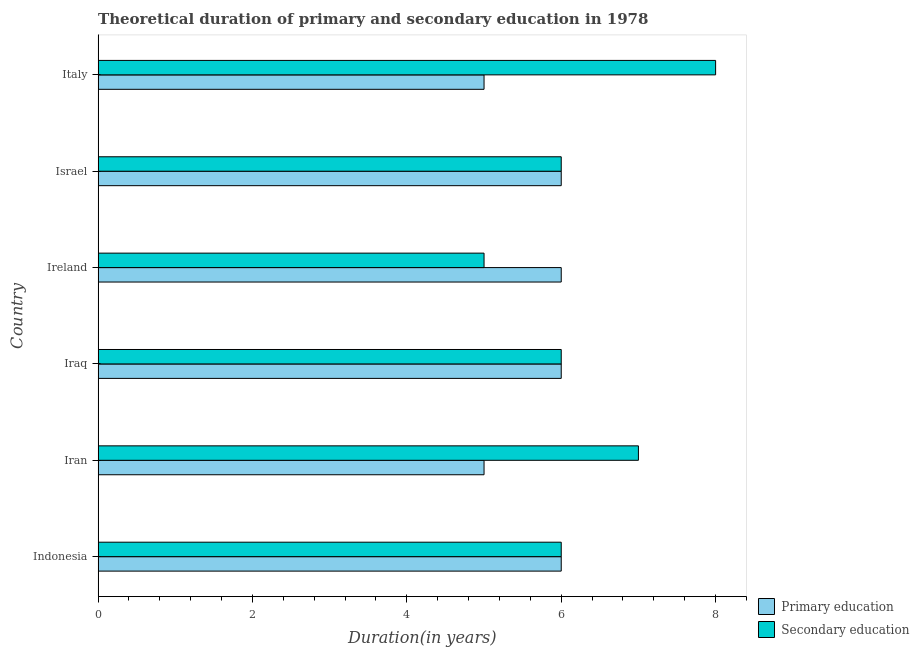How many groups of bars are there?
Provide a short and direct response. 6. How many bars are there on the 3rd tick from the top?
Offer a terse response. 2. How many bars are there on the 4th tick from the bottom?
Offer a terse response. 2. What is the label of the 5th group of bars from the top?
Provide a succinct answer. Iran. In how many cases, is the number of bars for a given country not equal to the number of legend labels?
Your response must be concise. 0. What is the duration of secondary education in Iran?
Offer a very short reply. 7. Across all countries, what is the maximum duration of secondary education?
Offer a very short reply. 8. Across all countries, what is the minimum duration of primary education?
Offer a very short reply. 5. In which country was the duration of secondary education minimum?
Your response must be concise. Ireland. What is the total duration of secondary education in the graph?
Your response must be concise. 38. What is the difference between the duration of secondary education in Indonesia and that in Italy?
Offer a very short reply. -2. What is the difference between the duration of primary education in Indonesia and the duration of secondary education in Iraq?
Keep it short and to the point. 0. What is the average duration of secondary education per country?
Your response must be concise. 6.33. In how many countries, is the duration of primary education greater than 4.4 years?
Offer a very short reply. 6. What is the ratio of the duration of secondary education in Iran to that in Israel?
Ensure brevity in your answer.  1.17. Is the duration of primary education in Iran less than that in Ireland?
Provide a short and direct response. Yes. Is the difference between the duration of primary education in Indonesia and Israel greater than the difference between the duration of secondary education in Indonesia and Israel?
Offer a very short reply. No. What is the difference between the highest and the second highest duration of secondary education?
Provide a succinct answer. 1. What is the difference between the highest and the lowest duration of secondary education?
Provide a succinct answer. 3. Is the sum of the duration of secondary education in Iran and Ireland greater than the maximum duration of primary education across all countries?
Provide a succinct answer. Yes. What does the 2nd bar from the top in Italy represents?
Ensure brevity in your answer.  Primary education. What does the 2nd bar from the bottom in Indonesia represents?
Offer a very short reply. Secondary education. How many bars are there?
Your answer should be very brief. 12. Are all the bars in the graph horizontal?
Provide a short and direct response. Yes. How many countries are there in the graph?
Offer a very short reply. 6. Does the graph contain grids?
Give a very brief answer. No. How are the legend labels stacked?
Your answer should be very brief. Vertical. What is the title of the graph?
Offer a terse response. Theoretical duration of primary and secondary education in 1978. Does "Ages 15-24" appear as one of the legend labels in the graph?
Provide a short and direct response. No. What is the label or title of the X-axis?
Your answer should be compact. Duration(in years). What is the Duration(in years) in Primary education in Indonesia?
Your answer should be compact. 6. What is the Duration(in years) of Secondary education in Indonesia?
Offer a terse response. 6. What is the Duration(in years) in Secondary education in Iraq?
Your answer should be very brief. 6. What is the Duration(in years) of Secondary education in Israel?
Provide a succinct answer. 6. What is the Duration(in years) of Primary education in Italy?
Your response must be concise. 5. Across all countries, what is the maximum Duration(in years) in Secondary education?
Offer a terse response. 8. What is the difference between the Duration(in years) of Primary education in Indonesia and that in Iran?
Offer a terse response. 1. What is the difference between the Duration(in years) of Primary education in Indonesia and that in Iraq?
Keep it short and to the point. 0. What is the difference between the Duration(in years) of Primary education in Indonesia and that in Ireland?
Your answer should be very brief. 0. What is the difference between the Duration(in years) of Secondary education in Iran and that in Iraq?
Offer a terse response. 1. What is the difference between the Duration(in years) of Secondary education in Iran and that in Ireland?
Provide a succinct answer. 2. What is the difference between the Duration(in years) of Primary education in Iran and that in Israel?
Provide a succinct answer. -1. What is the difference between the Duration(in years) in Secondary education in Iran and that in Israel?
Your answer should be very brief. 1. What is the difference between the Duration(in years) of Secondary education in Ireland and that in Israel?
Offer a very short reply. -1. What is the difference between the Duration(in years) of Primary education in Ireland and that in Italy?
Give a very brief answer. 1. What is the difference between the Duration(in years) of Secondary education in Israel and that in Italy?
Offer a terse response. -2. What is the difference between the Duration(in years) in Primary education in Indonesia and the Duration(in years) in Secondary education in Iraq?
Ensure brevity in your answer.  0. What is the difference between the Duration(in years) in Primary education in Indonesia and the Duration(in years) in Secondary education in Ireland?
Ensure brevity in your answer.  1. What is the difference between the Duration(in years) in Primary education in Indonesia and the Duration(in years) in Secondary education in Israel?
Your answer should be very brief. 0. What is the difference between the Duration(in years) in Primary education in Indonesia and the Duration(in years) in Secondary education in Italy?
Ensure brevity in your answer.  -2. What is the difference between the Duration(in years) in Primary education in Iran and the Duration(in years) in Secondary education in Ireland?
Your answer should be very brief. 0. What is the difference between the Duration(in years) of Primary education in Iran and the Duration(in years) of Secondary education in Italy?
Your answer should be very brief. -3. What is the difference between the Duration(in years) in Primary education in Iraq and the Duration(in years) in Secondary education in Ireland?
Provide a succinct answer. 1. What is the difference between the Duration(in years) in Primary education in Ireland and the Duration(in years) in Secondary education in Israel?
Provide a short and direct response. 0. What is the difference between the Duration(in years) in Primary education in Israel and the Duration(in years) in Secondary education in Italy?
Your answer should be compact. -2. What is the average Duration(in years) of Primary education per country?
Ensure brevity in your answer.  5.67. What is the average Duration(in years) of Secondary education per country?
Your response must be concise. 6.33. What is the difference between the Duration(in years) in Primary education and Duration(in years) in Secondary education in Indonesia?
Make the answer very short. 0. What is the difference between the Duration(in years) of Primary education and Duration(in years) of Secondary education in Iraq?
Provide a succinct answer. 0. What is the difference between the Duration(in years) in Primary education and Duration(in years) in Secondary education in Israel?
Offer a very short reply. 0. What is the difference between the Duration(in years) in Primary education and Duration(in years) in Secondary education in Italy?
Offer a very short reply. -3. What is the ratio of the Duration(in years) of Secondary education in Indonesia to that in Iraq?
Ensure brevity in your answer.  1. What is the ratio of the Duration(in years) of Primary education in Indonesia to that in Ireland?
Offer a terse response. 1. What is the ratio of the Duration(in years) in Secondary education in Indonesia to that in Ireland?
Give a very brief answer. 1.2. What is the ratio of the Duration(in years) in Primary education in Indonesia to that in Israel?
Your response must be concise. 1. What is the ratio of the Duration(in years) in Secondary education in Iran to that in Iraq?
Offer a terse response. 1.17. What is the ratio of the Duration(in years) of Primary education in Iran to that in Ireland?
Offer a very short reply. 0.83. What is the ratio of the Duration(in years) in Primary education in Iran to that in Israel?
Your answer should be very brief. 0.83. What is the ratio of the Duration(in years) in Secondary education in Iran to that in Israel?
Ensure brevity in your answer.  1.17. What is the ratio of the Duration(in years) of Primary education in Iran to that in Italy?
Keep it short and to the point. 1. What is the ratio of the Duration(in years) in Secondary education in Iran to that in Italy?
Provide a succinct answer. 0.88. What is the ratio of the Duration(in years) in Primary education in Iraq to that in Israel?
Keep it short and to the point. 1. What is the ratio of the Duration(in years) in Primary education in Iraq to that in Italy?
Provide a succinct answer. 1.2. What is the ratio of the Duration(in years) in Secondary education in Iraq to that in Italy?
Provide a short and direct response. 0.75. What is the ratio of the Duration(in years) in Primary education in Ireland to that in Israel?
Offer a very short reply. 1. What is the ratio of the Duration(in years) in Secondary education in Ireland to that in Israel?
Your answer should be very brief. 0.83. What is the ratio of the Duration(in years) of Primary education in Ireland to that in Italy?
Ensure brevity in your answer.  1.2. What is the ratio of the Duration(in years) in Secondary education in Israel to that in Italy?
Offer a terse response. 0.75. 